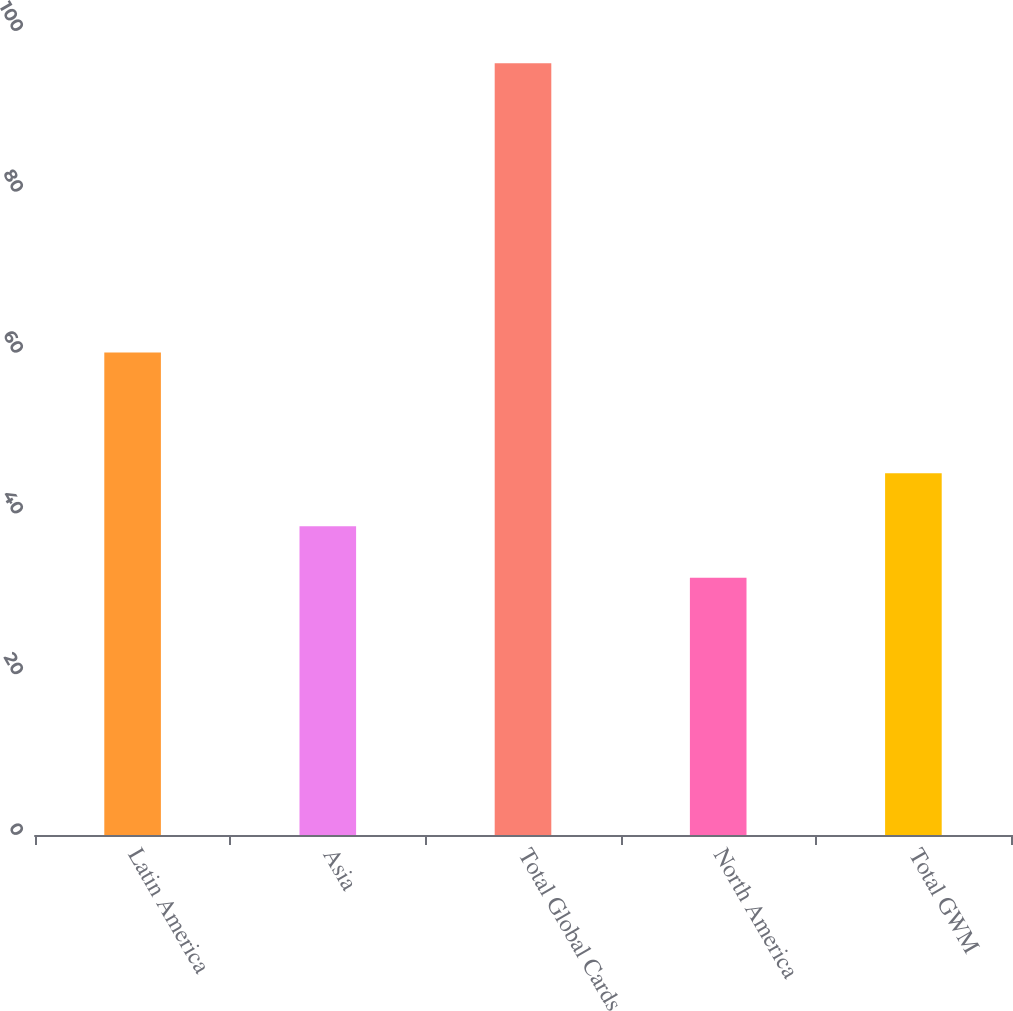Convert chart. <chart><loc_0><loc_0><loc_500><loc_500><bar_chart><fcel>Latin America<fcel>Asia<fcel>Total Global Cards<fcel>North America<fcel>Total GWM<nl><fcel>60<fcel>38.4<fcel>96<fcel>32<fcel>45<nl></chart> 